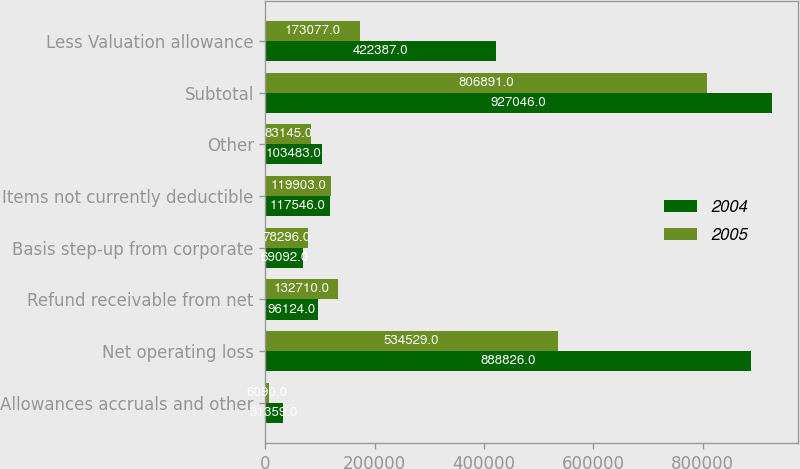Convert chart. <chart><loc_0><loc_0><loc_500><loc_500><stacked_bar_chart><ecel><fcel>Allowances accruals and other<fcel>Net operating loss<fcel>Refund receivable from net<fcel>Basis step-up from corporate<fcel>Items not currently deductible<fcel>Other<fcel>Subtotal<fcel>Less Valuation allowance<nl><fcel>2004<fcel>31359<fcel>888826<fcel>96124<fcel>69092<fcel>117546<fcel>103483<fcel>927046<fcel>422387<nl><fcel>2005<fcel>6090<fcel>534529<fcel>132710<fcel>78296<fcel>119903<fcel>83145<fcel>806891<fcel>173077<nl></chart> 